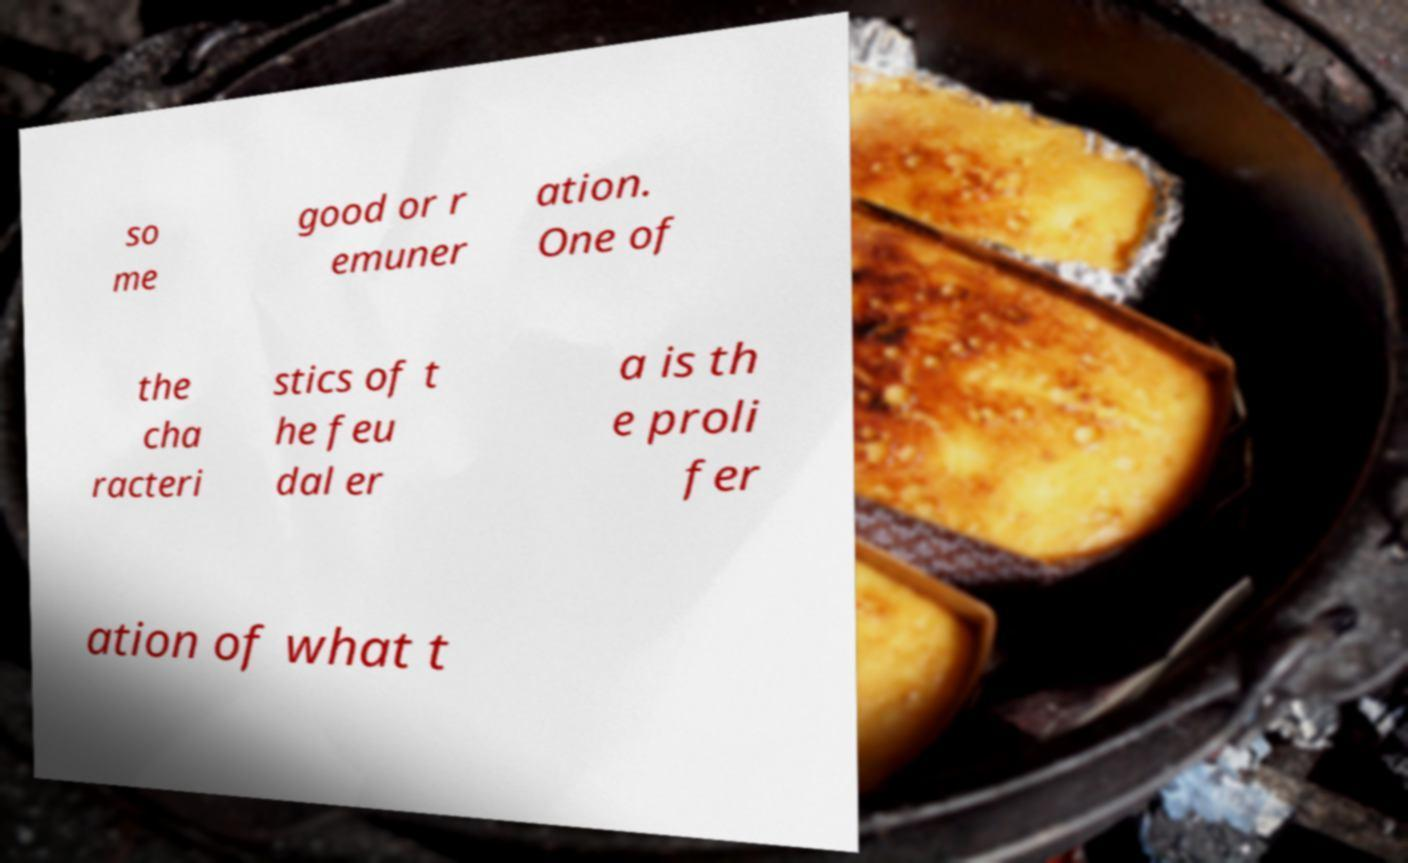Could you extract and type out the text from this image? so me good or r emuner ation. One of the cha racteri stics of t he feu dal er a is th e proli fer ation of what t 